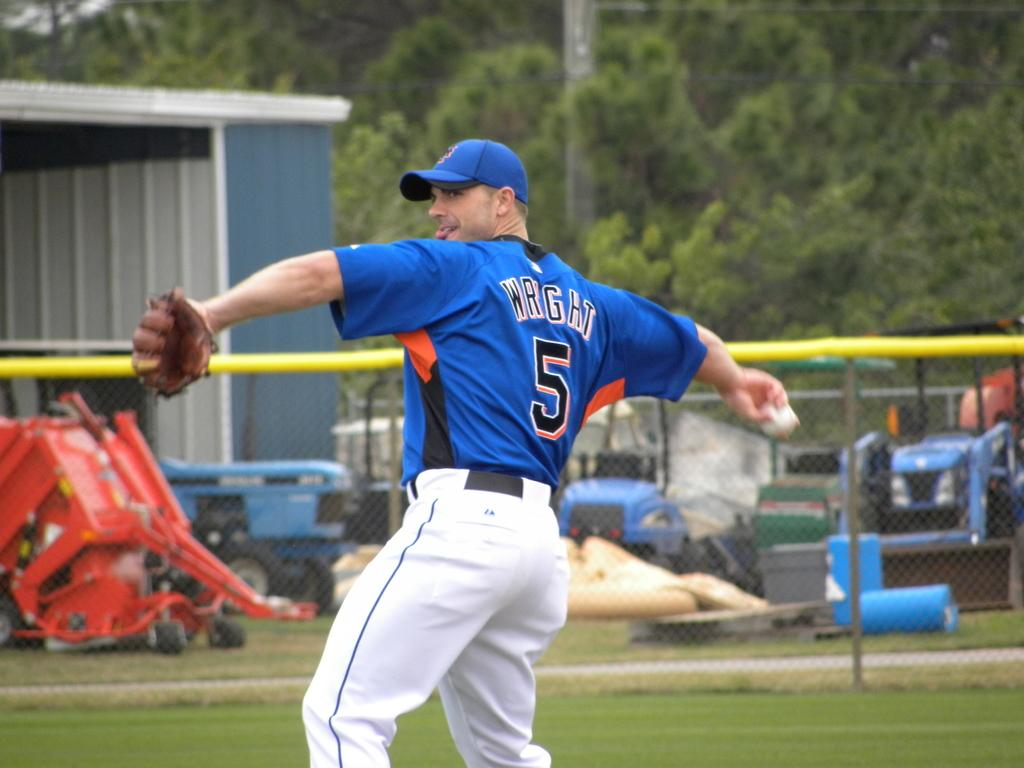<image>
Render a clear and concise summary of the photo. The baseball player is named Wright, and he is throwing a ball. 